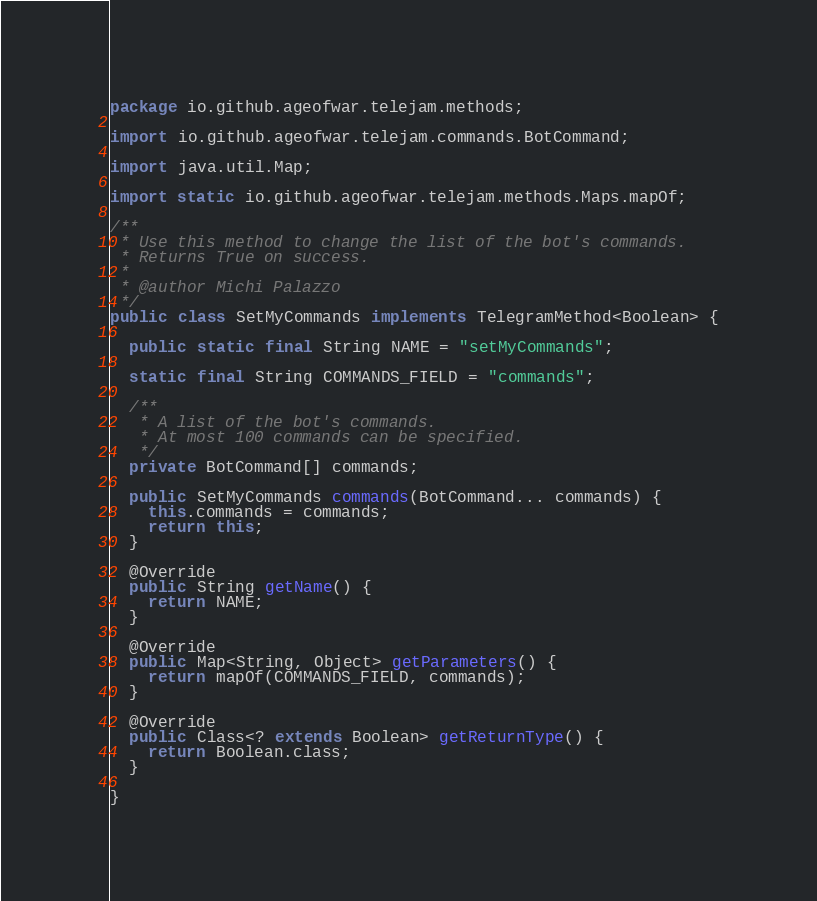Convert code to text. <code><loc_0><loc_0><loc_500><loc_500><_Java_>package io.github.ageofwar.telejam.methods;

import io.github.ageofwar.telejam.commands.BotCommand;

import java.util.Map;

import static io.github.ageofwar.telejam.methods.Maps.mapOf;

/**
 * Use this method to change the list of the bot's commands.
 * Returns True on success.
 *
 * @author Michi Palazzo
 */
public class SetMyCommands implements TelegramMethod<Boolean> {
  
  public static final String NAME = "setMyCommands";
  
  static final String COMMANDS_FIELD = "commands";
  
  /**
   * A list of the bot's commands.
   * At most 100 commands can be specified.
   */
  private BotCommand[] commands;
  
  public SetMyCommands commands(BotCommand... commands) {
    this.commands = commands;
    return this;
  }
  
  @Override
  public String getName() {
    return NAME;
  }
  
  @Override
  public Map<String, Object> getParameters() {
    return mapOf(COMMANDS_FIELD, commands);
  }
  
  @Override
  public Class<? extends Boolean> getReturnType() {
    return Boolean.class;
  }
  
}

</code> 